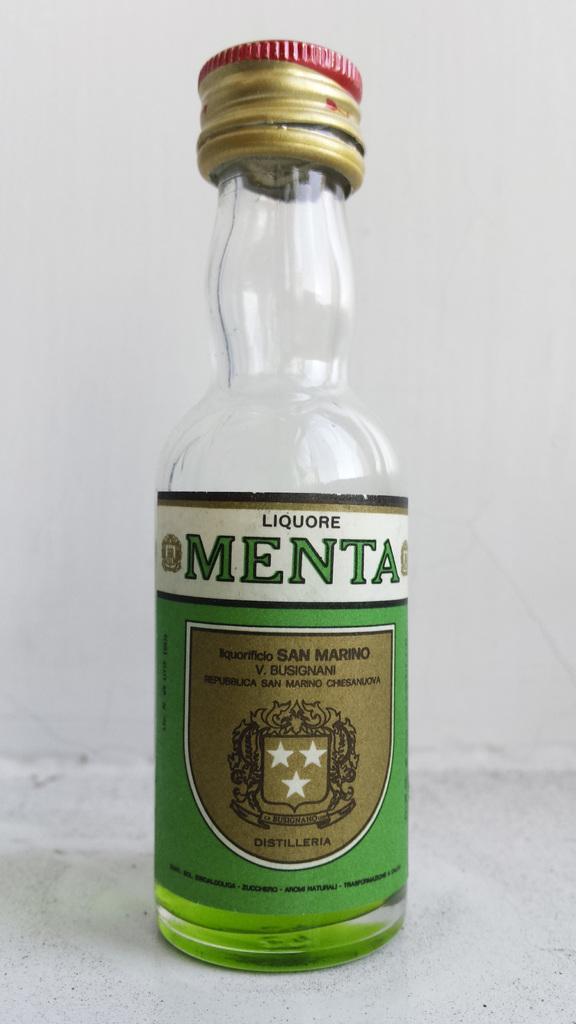Can you describe this image briefly? In the center we can see one bottle written as "Meta". In the background there is a wall. 